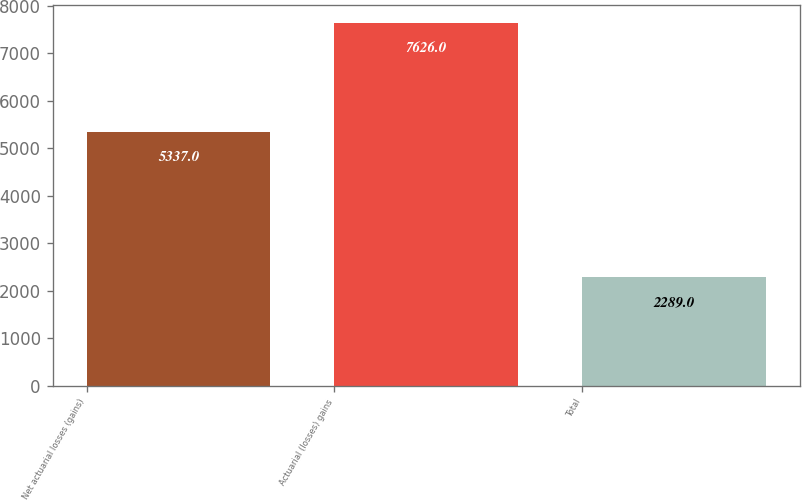Convert chart. <chart><loc_0><loc_0><loc_500><loc_500><bar_chart><fcel>Net actuarial losses (gains)<fcel>Actuarial (losses) gains<fcel>Total<nl><fcel>5337<fcel>7626<fcel>2289<nl></chart> 